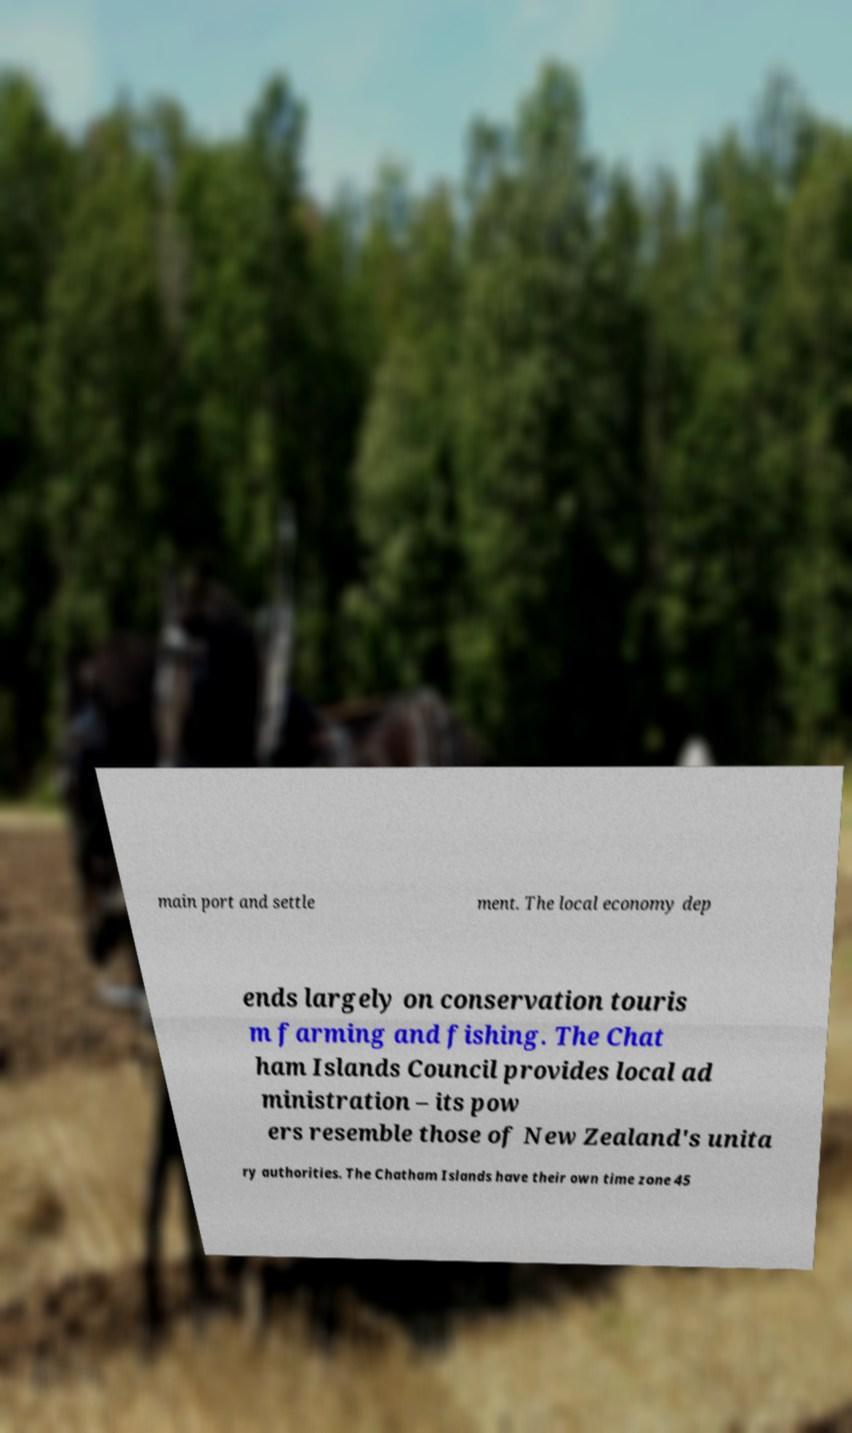Can you accurately transcribe the text from the provided image for me? main port and settle ment. The local economy dep ends largely on conservation touris m farming and fishing. The Chat ham Islands Council provides local ad ministration – its pow ers resemble those of New Zealand's unita ry authorities. The Chatham Islands have their own time zone 45 